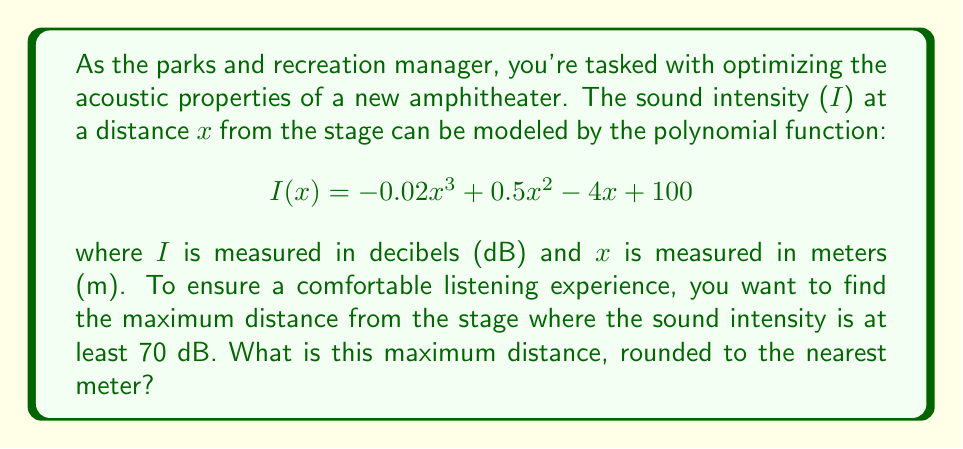Help me with this question. To solve this problem, we need to follow these steps:

1) We're looking for the largest value of x where I(x) ≥ 70 dB.

2) This can be represented by the inequality:
   $$-0.02x^3 + 0.5x^2 - 4x + 100 \geq 70$$

3) Rearranging the inequality:
   $$-0.02x^3 + 0.5x^2 - 4x + 30 \geq 0$$

4) This is a cubic inequality. To solve it, we need to find the roots of the corresponding equation:
   $$-0.02x^3 + 0.5x^2 - 4x + 30 = 0$$

5) This equation doesn't have an easy factorization, so we need to use numerical methods or a graphing calculator to find its roots.

6) Using a graphing calculator or computer algebra system, we find that this equation has three real roots: approximately -1.39, 5.76, and 20.63.

7) The inequality is satisfied when x is between 5.76 and 20.63 (you can verify this by testing points in each interval).

8) Since we're looking for the maximum distance, we want the larger of these two values: 20.63.

9) Rounding to the nearest meter gives us 21 meters.

Therefore, the maximum distance from the stage where the sound intensity is at least 70 dB is 21 meters.
Answer: 21 meters 